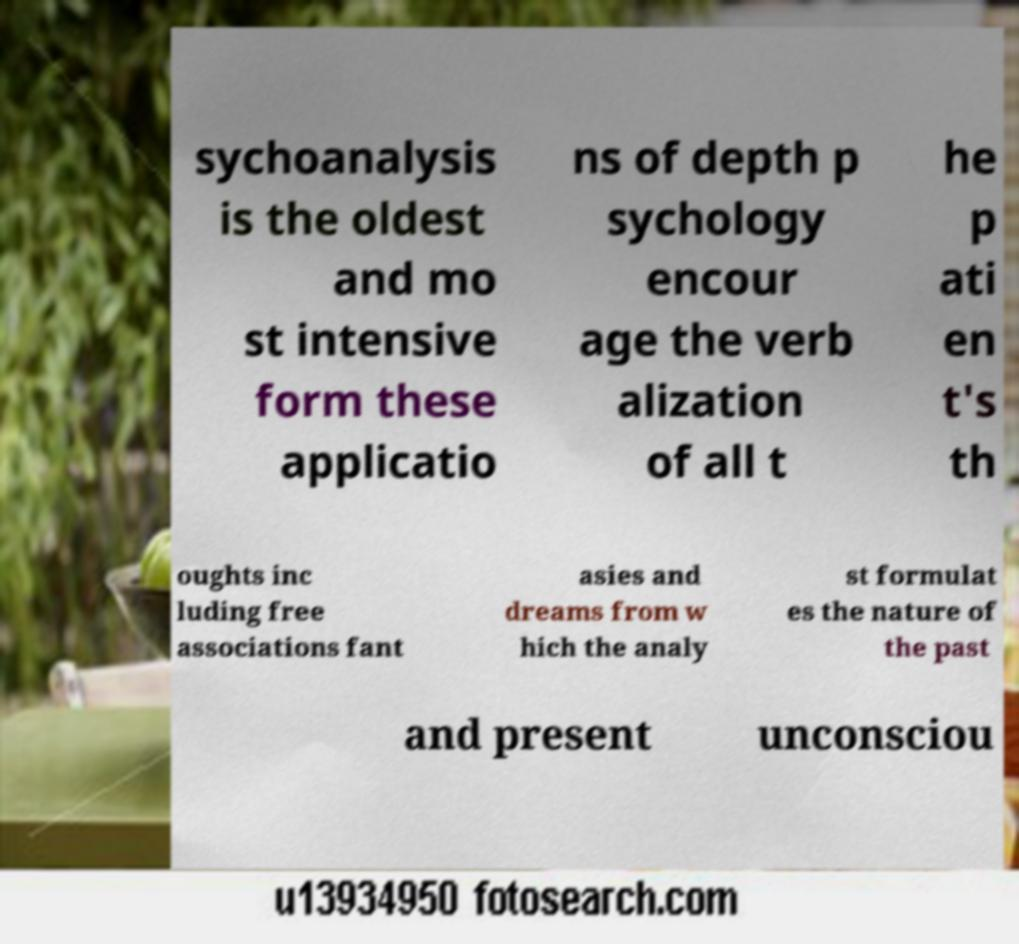Can you accurately transcribe the text from the provided image for me? sychoanalysis is the oldest and mo st intensive form these applicatio ns of depth p sychology encour age the verb alization of all t he p ati en t's th oughts inc luding free associations fant asies and dreams from w hich the analy st formulat es the nature of the past and present unconsciou 